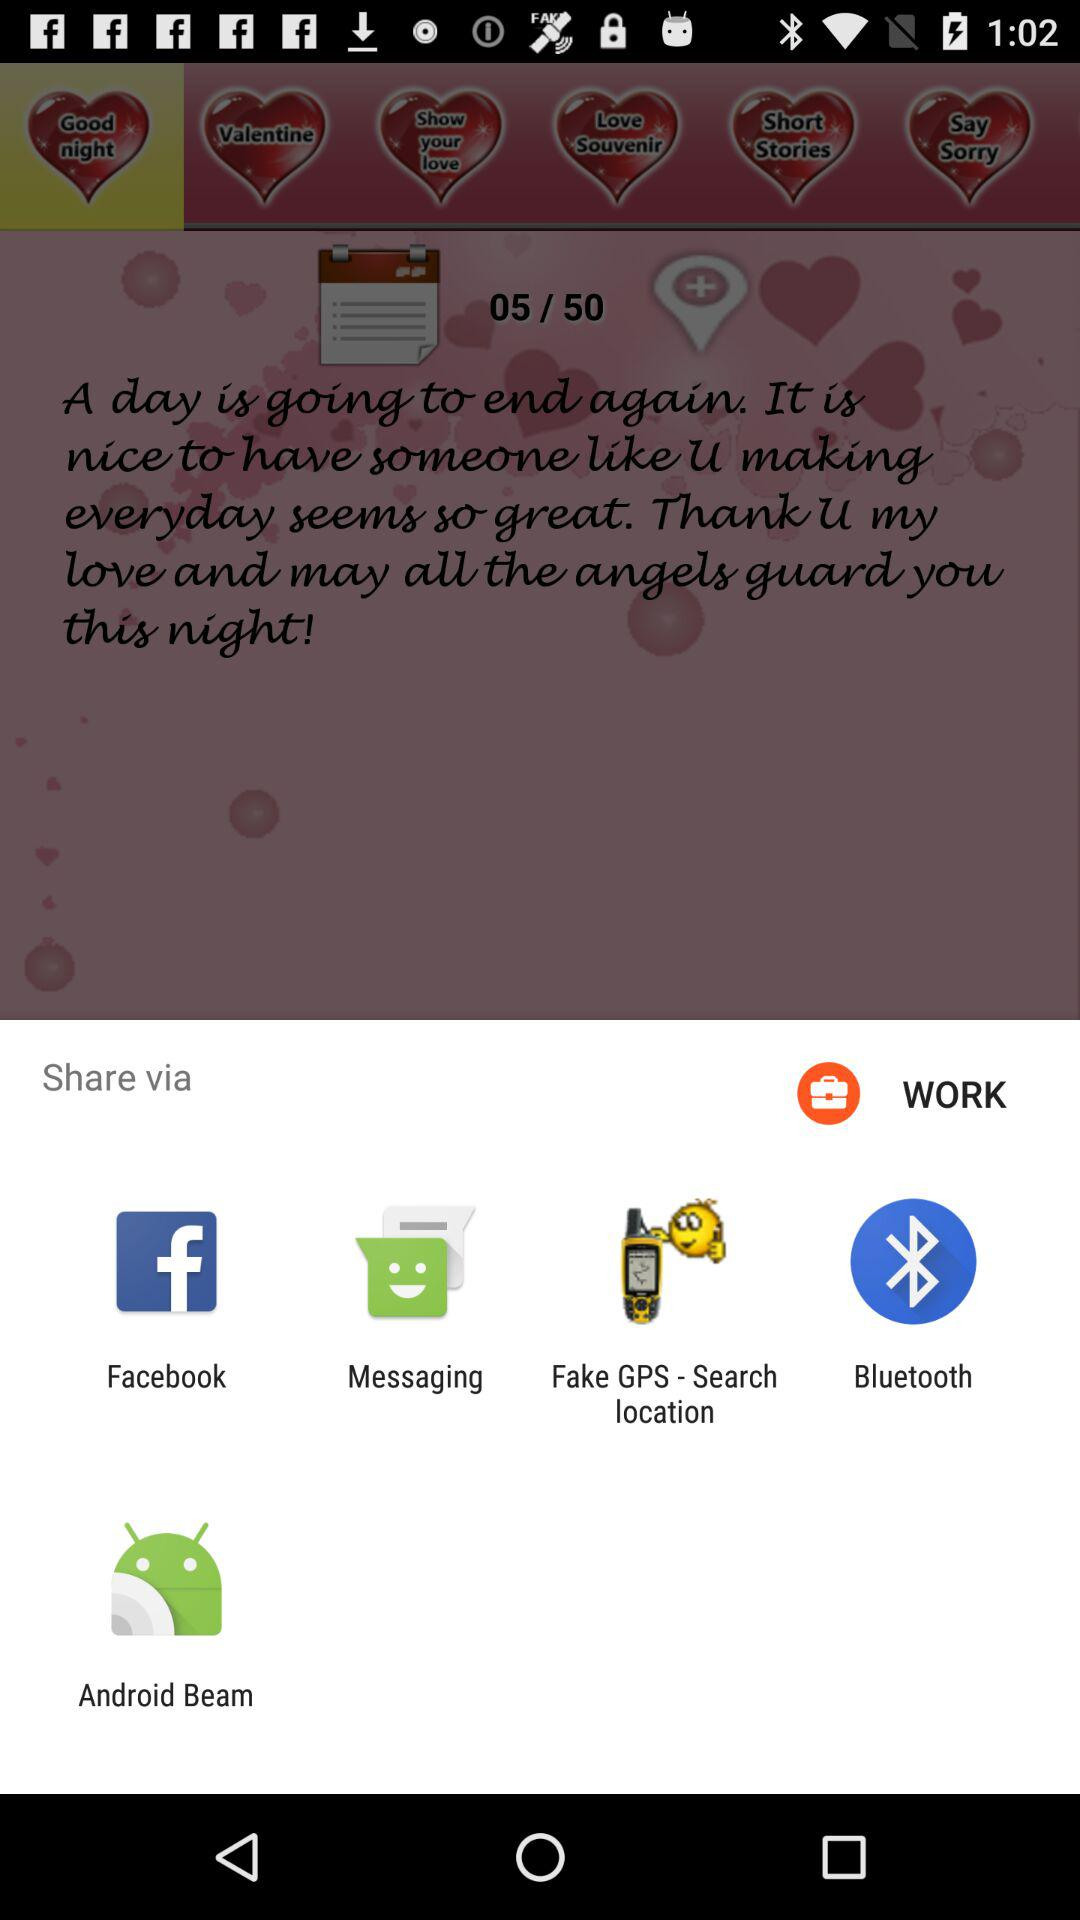Which options are given for sharing? The options "Facebook", "Messaging", "Fake GPS - Search location", "Bluetooth" and "Android Beam" are given for sharing. 